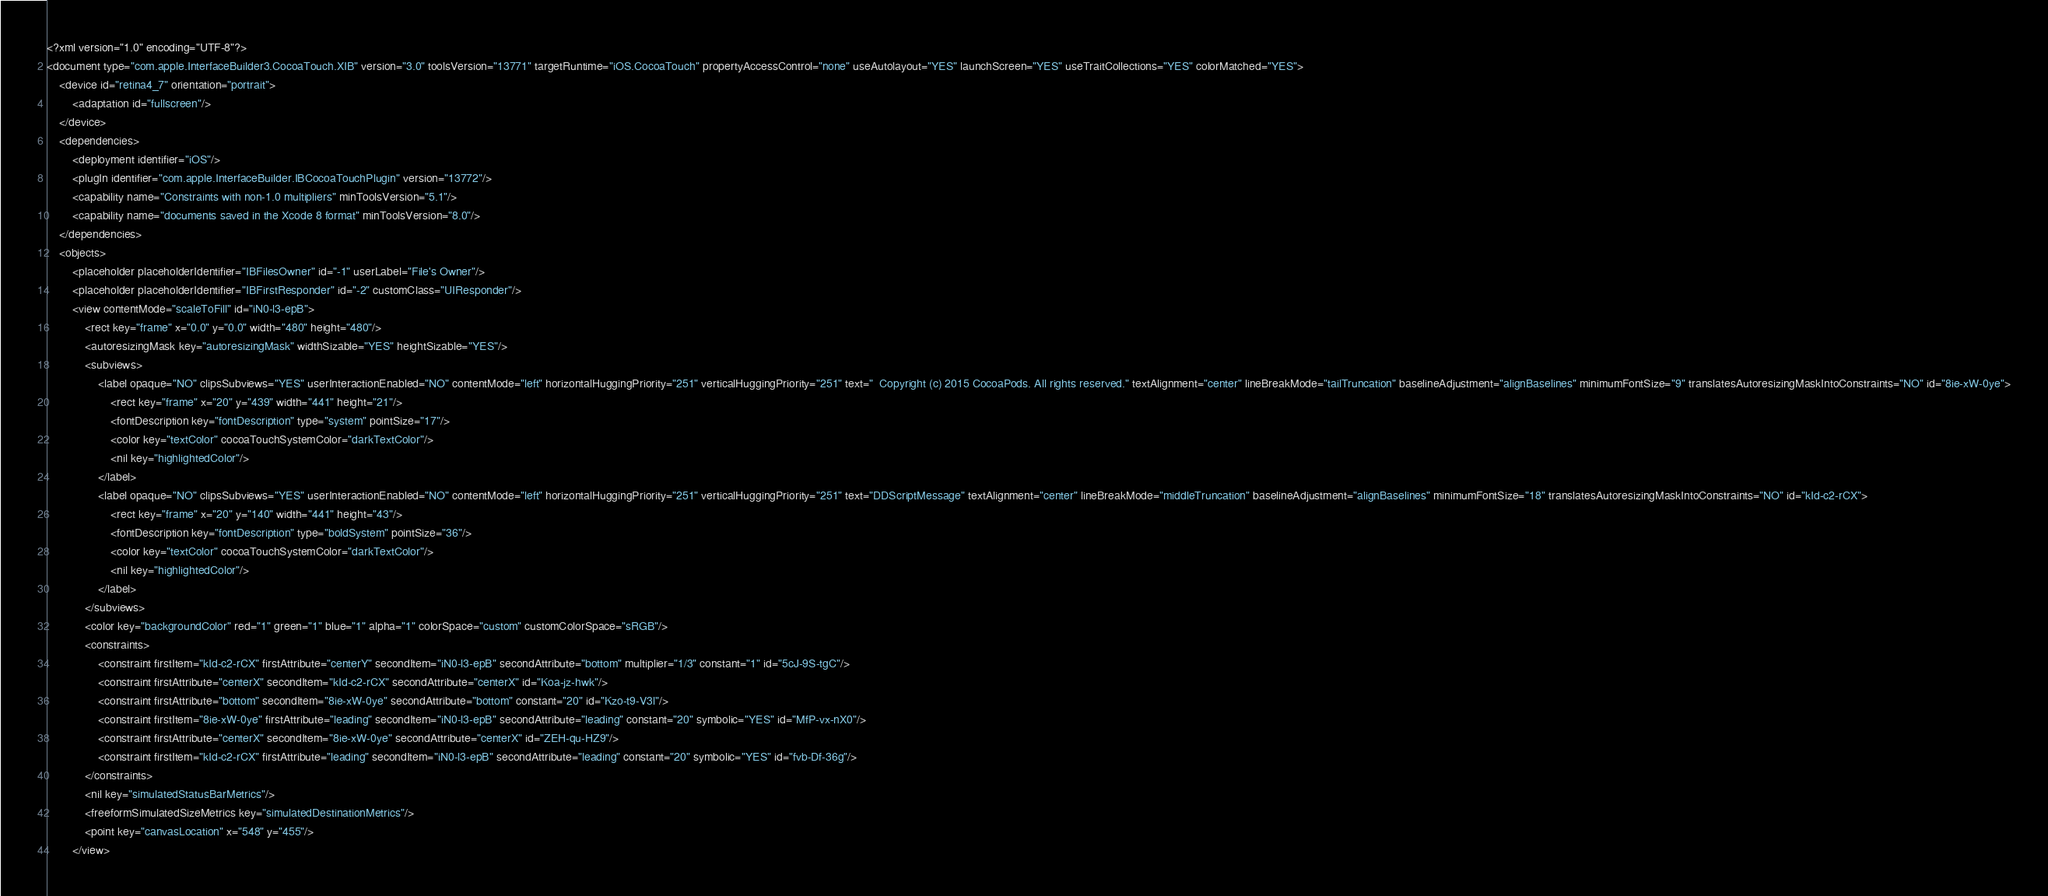Convert code to text. <code><loc_0><loc_0><loc_500><loc_500><_XML_><?xml version="1.0" encoding="UTF-8"?>
<document type="com.apple.InterfaceBuilder3.CocoaTouch.XIB" version="3.0" toolsVersion="13771" targetRuntime="iOS.CocoaTouch" propertyAccessControl="none" useAutolayout="YES" launchScreen="YES" useTraitCollections="YES" colorMatched="YES">
    <device id="retina4_7" orientation="portrait">
        <adaptation id="fullscreen"/>
    </device>
    <dependencies>
        <deployment identifier="iOS"/>
        <plugIn identifier="com.apple.InterfaceBuilder.IBCocoaTouchPlugin" version="13772"/>
        <capability name="Constraints with non-1.0 multipliers" minToolsVersion="5.1"/>
        <capability name="documents saved in the Xcode 8 format" minToolsVersion="8.0"/>
    </dependencies>
    <objects>
        <placeholder placeholderIdentifier="IBFilesOwner" id="-1" userLabel="File's Owner"/>
        <placeholder placeholderIdentifier="IBFirstResponder" id="-2" customClass="UIResponder"/>
        <view contentMode="scaleToFill" id="iN0-l3-epB">
            <rect key="frame" x="0.0" y="0.0" width="480" height="480"/>
            <autoresizingMask key="autoresizingMask" widthSizable="YES" heightSizable="YES"/>
            <subviews>
                <label opaque="NO" clipsSubviews="YES" userInteractionEnabled="NO" contentMode="left" horizontalHuggingPriority="251" verticalHuggingPriority="251" text="  Copyright (c) 2015 CocoaPods. All rights reserved." textAlignment="center" lineBreakMode="tailTruncation" baselineAdjustment="alignBaselines" minimumFontSize="9" translatesAutoresizingMaskIntoConstraints="NO" id="8ie-xW-0ye">
                    <rect key="frame" x="20" y="439" width="441" height="21"/>
                    <fontDescription key="fontDescription" type="system" pointSize="17"/>
                    <color key="textColor" cocoaTouchSystemColor="darkTextColor"/>
                    <nil key="highlightedColor"/>
                </label>
                <label opaque="NO" clipsSubviews="YES" userInteractionEnabled="NO" contentMode="left" horizontalHuggingPriority="251" verticalHuggingPriority="251" text="DDScriptMessage" textAlignment="center" lineBreakMode="middleTruncation" baselineAdjustment="alignBaselines" minimumFontSize="18" translatesAutoresizingMaskIntoConstraints="NO" id="kId-c2-rCX">
                    <rect key="frame" x="20" y="140" width="441" height="43"/>
                    <fontDescription key="fontDescription" type="boldSystem" pointSize="36"/>
                    <color key="textColor" cocoaTouchSystemColor="darkTextColor"/>
                    <nil key="highlightedColor"/>
                </label>
            </subviews>
            <color key="backgroundColor" red="1" green="1" blue="1" alpha="1" colorSpace="custom" customColorSpace="sRGB"/>
            <constraints>
                <constraint firstItem="kId-c2-rCX" firstAttribute="centerY" secondItem="iN0-l3-epB" secondAttribute="bottom" multiplier="1/3" constant="1" id="5cJ-9S-tgC"/>
                <constraint firstAttribute="centerX" secondItem="kId-c2-rCX" secondAttribute="centerX" id="Koa-jz-hwk"/>
                <constraint firstAttribute="bottom" secondItem="8ie-xW-0ye" secondAttribute="bottom" constant="20" id="Kzo-t9-V3l"/>
                <constraint firstItem="8ie-xW-0ye" firstAttribute="leading" secondItem="iN0-l3-epB" secondAttribute="leading" constant="20" symbolic="YES" id="MfP-vx-nX0"/>
                <constraint firstAttribute="centerX" secondItem="8ie-xW-0ye" secondAttribute="centerX" id="ZEH-qu-HZ9"/>
                <constraint firstItem="kId-c2-rCX" firstAttribute="leading" secondItem="iN0-l3-epB" secondAttribute="leading" constant="20" symbolic="YES" id="fvb-Df-36g"/>
            </constraints>
            <nil key="simulatedStatusBarMetrics"/>
            <freeformSimulatedSizeMetrics key="simulatedDestinationMetrics"/>
            <point key="canvasLocation" x="548" y="455"/>
        </view></code> 